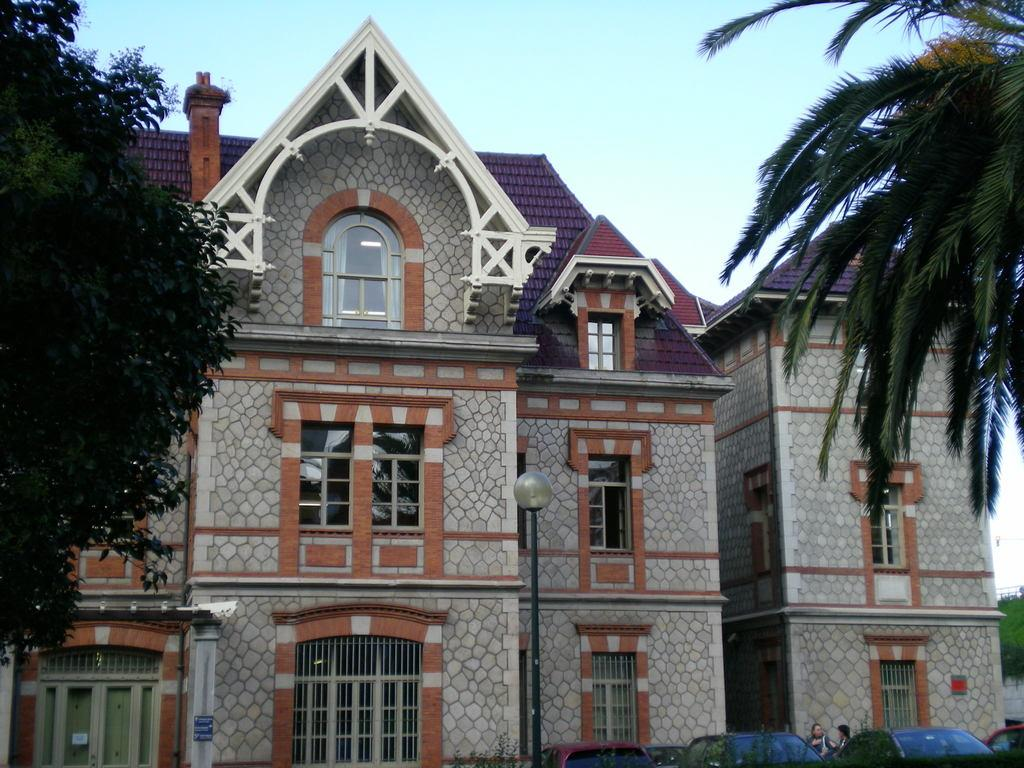What is located in the center of the image? There are houses in the center of the image. What type of vegetation can be seen on the right side of the image? There are trees on the right side of the image. What type of vegetation can be seen on the left side of the image? There are trees on the left side of the image. What type of vehicles are at the bottom side of the image? There are cars at the bottom side of the image. How many dogs are playing with the baby in the image? There are no dogs or baby present in the image; it features houses, trees, and cars. What type of lunch is being served in the image? There is no lunch present in the image. 